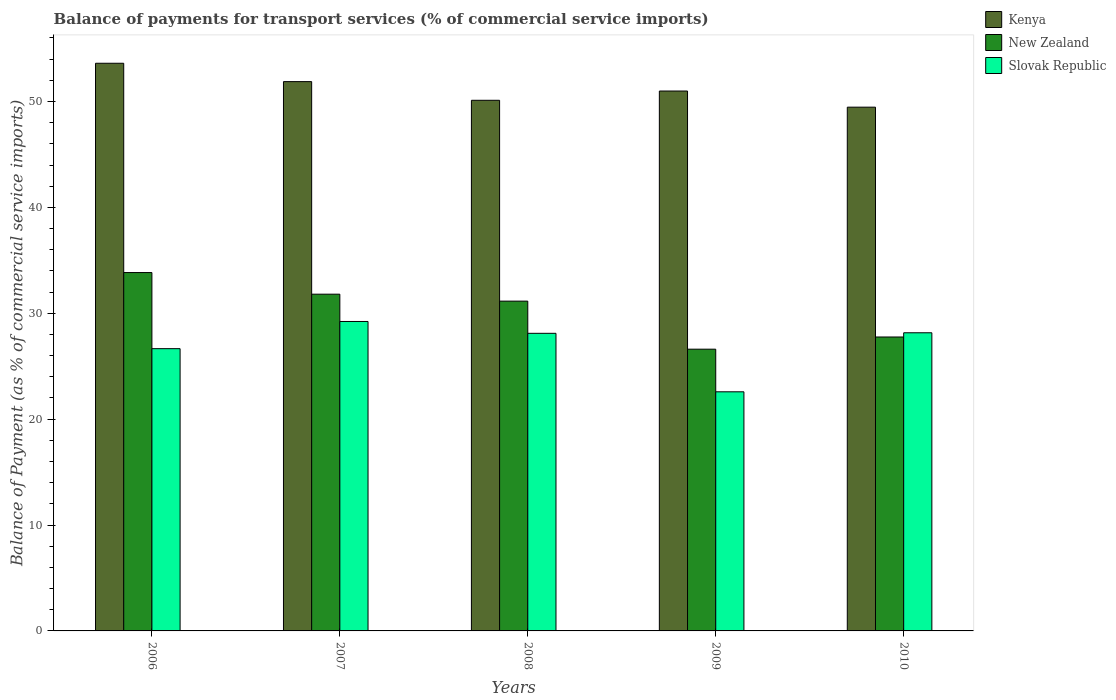How many different coloured bars are there?
Ensure brevity in your answer.  3. How many groups of bars are there?
Your answer should be very brief. 5. Are the number of bars per tick equal to the number of legend labels?
Keep it short and to the point. Yes. Are the number of bars on each tick of the X-axis equal?
Your answer should be very brief. Yes. What is the label of the 3rd group of bars from the left?
Give a very brief answer. 2008. In how many cases, is the number of bars for a given year not equal to the number of legend labels?
Make the answer very short. 0. What is the balance of payments for transport services in New Zealand in 2007?
Make the answer very short. 31.8. Across all years, what is the maximum balance of payments for transport services in Slovak Republic?
Your answer should be very brief. 29.23. Across all years, what is the minimum balance of payments for transport services in New Zealand?
Give a very brief answer. 26.61. In which year was the balance of payments for transport services in Kenya maximum?
Give a very brief answer. 2006. What is the total balance of payments for transport services in Slovak Republic in the graph?
Provide a short and direct response. 134.74. What is the difference between the balance of payments for transport services in Kenya in 2009 and that in 2010?
Make the answer very short. 1.53. What is the difference between the balance of payments for transport services in Slovak Republic in 2010 and the balance of payments for transport services in Kenya in 2009?
Provide a succinct answer. -22.83. What is the average balance of payments for transport services in Kenya per year?
Your response must be concise. 51.21. In the year 2009, what is the difference between the balance of payments for transport services in Slovak Republic and balance of payments for transport services in Kenya?
Offer a very short reply. -28.41. What is the ratio of the balance of payments for transport services in Slovak Republic in 2006 to that in 2010?
Keep it short and to the point. 0.95. What is the difference between the highest and the second highest balance of payments for transport services in Kenya?
Provide a short and direct response. 1.73. What is the difference between the highest and the lowest balance of payments for transport services in New Zealand?
Offer a very short reply. 7.24. In how many years, is the balance of payments for transport services in New Zealand greater than the average balance of payments for transport services in New Zealand taken over all years?
Your answer should be very brief. 3. Is the sum of the balance of payments for transport services in New Zealand in 2008 and 2009 greater than the maximum balance of payments for transport services in Slovak Republic across all years?
Give a very brief answer. Yes. What does the 3rd bar from the left in 2009 represents?
Provide a succinct answer. Slovak Republic. What does the 1st bar from the right in 2006 represents?
Your response must be concise. Slovak Republic. Is it the case that in every year, the sum of the balance of payments for transport services in Slovak Republic and balance of payments for transport services in New Zealand is greater than the balance of payments for transport services in Kenya?
Ensure brevity in your answer.  No. Are all the bars in the graph horizontal?
Make the answer very short. No. How many years are there in the graph?
Give a very brief answer. 5. What is the title of the graph?
Provide a succinct answer. Balance of payments for transport services (% of commercial service imports). Does "Korea (Republic)" appear as one of the legend labels in the graph?
Make the answer very short. No. What is the label or title of the X-axis?
Make the answer very short. Years. What is the label or title of the Y-axis?
Ensure brevity in your answer.  Balance of Payment (as % of commercial service imports). What is the Balance of Payment (as % of commercial service imports) in Kenya in 2006?
Your response must be concise. 53.61. What is the Balance of Payment (as % of commercial service imports) of New Zealand in 2006?
Keep it short and to the point. 33.85. What is the Balance of Payment (as % of commercial service imports) in Slovak Republic in 2006?
Your answer should be very brief. 26.66. What is the Balance of Payment (as % of commercial service imports) in Kenya in 2007?
Give a very brief answer. 51.88. What is the Balance of Payment (as % of commercial service imports) of New Zealand in 2007?
Provide a succinct answer. 31.8. What is the Balance of Payment (as % of commercial service imports) in Slovak Republic in 2007?
Ensure brevity in your answer.  29.23. What is the Balance of Payment (as % of commercial service imports) in Kenya in 2008?
Provide a short and direct response. 50.12. What is the Balance of Payment (as % of commercial service imports) in New Zealand in 2008?
Your answer should be compact. 31.15. What is the Balance of Payment (as % of commercial service imports) in Slovak Republic in 2008?
Ensure brevity in your answer.  28.11. What is the Balance of Payment (as % of commercial service imports) in Kenya in 2009?
Offer a very short reply. 50.99. What is the Balance of Payment (as % of commercial service imports) of New Zealand in 2009?
Your response must be concise. 26.61. What is the Balance of Payment (as % of commercial service imports) in Slovak Republic in 2009?
Give a very brief answer. 22.58. What is the Balance of Payment (as % of commercial service imports) of Kenya in 2010?
Offer a very short reply. 49.47. What is the Balance of Payment (as % of commercial service imports) of New Zealand in 2010?
Offer a very short reply. 27.76. What is the Balance of Payment (as % of commercial service imports) in Slovak Republic in 2010?
Provide a succinct answer. 28.16. Across all years, what is the maximum Balance of Payment (as % of commercial service imports) in Kenya?
Your answer should be very brief. 53.61. Across all years, what is the maximum Balance of Payment (as % of commercial service imports) in New Zealand?
Offer a very short reply. 33.85. Across all years, what is the maximum Balance of Payment (as % of commercial service imports) of Slovak Republic?
Keep it short and to the point. 29.23. Across all years, what is the minimum Balance of Payment (as % of commercial service imports) of Kenya?
Offer a very short reply. 49.47. Across all years, what is the minimum Balance of Payment (as % of commercial service imports) of New Zealand?
Keep it short and to the point. 26.61. Across all years, what is the minimum Balance of Payment (as % of commercial service imports) of Slovak Republic?
Offer a terse response. 22.58. What is the total Balance of Payment (as % of commercial service imports) in Kenya in the graph?
Give a very brief answer. 256.07. What is the total Balance of Payment (as % of commercial service imports) in New Zealand in the graph?
Make the answer very short. 151.17. What is the total Balance of Payment (as % of commercial service imports) in Slovak Republic in the graph?
Provide a succinct answer. 134.74. What is the difference between the Balance of Payment (as % of commercial service imports) in Kenya in 2006 and that in 2007?
Keep it short and to the point. 1.73. What is the difference between the Balance of Payment (as % of commercial service imports) in New Zealand in 2006 and that in 2007?
Your answer should be very brief. 2.04. What is the difference between the Balance of Payment (as % of commercial service imports) in Slovak Republic in 2006 and that in 2007?
Provide a short and direct response. -2.57. What is the difference between the Balance of Payment (as % of commercial service imports) of Kenya in 2006 and that in 2008?
Your answer should be compact. 3.5. What is the difference between the Balance of Payment (as % of commercial service imports) of New Zealand in 2006 and that in 2008?
Keep it short and to the point. 2.7. What is the difference between the Balance of Payment (as % of commercial service imports) of Slovak Republic in 2006 and that in 2008?
Offer a very short reply. -1.45. What is the difference between the Balance of Payment (as % of commercial service imports) in Kenya in 2006 and that in 2009?
Offer a very short reply. 2.62. What is the difference between the Balance of Payment (as % of commercial service imports) of New Zealand in 2006 and that in 2009?
Give a very brief answer. 7.24. What is the difference between the Balance of Payment (as % of commercial service imports) in Slovak Republic in 2006 and that in 2009?
Provide a succinct answer. 4.08. What is the difference between the Balance of Payment (as % of commercial service imports) of Kenya in 2006 and that in 2010?
Give a very brief answer. 4.15. What is the difference between the Balance of Payment (as % of commercial service imports) of New Zealand in 2006 and that in 2010?
Keep it short and to the point. 6.09. What is the difference between the Balance of Payment (as % of commercial service imports) of Slovak Republic in 2006 and that in 2010?
Keep it short and to the point. -1.5. What is the difference between the Balance of Payment (as % of commercial service imports) in Kenya in 2007 and that in 2008?
Make the answer very short. 1.76. What is the difference between the Balance of Payment (as % of commercial service imports) of New Zealand in 2007 and that in 2008?
Keep it short and to the point. 0.66. What is the difference between the Balance of Payment (as % of commercial service imports) in Slovak Republic in 2007 and that in 2008?
Make the answer very short. 1.12. What is the difference between the Balance of Payment (as % of commercial service imports) of Kenya in 2007 and that in 2009?
Keep it short and to the point. 0.89. What is the difference between the Balance of Payment (as % of commercial service imports) in New Zealand in 2007 and that in 2009?
Give a very brief answer. 5.2. What is the difference between the Balance of Payment (as % of commercial service imports) in Slovak Republic in 2007 and that in 2009?
Give a very brief answer. 6.64. What is the difference between the Balance of Payment (as % of commercial service imports) in Kenya in 2007 and that in 2010?
Ensure brevity in your answer.  2.41. What is the difference between the Balance of Payment (as % of commercial service imports) of New Zealand in 2007 and that in 2010?
Provide a succinct answer. 4.04. What is the difference between the Balance of Payment (as % of commercial service imports) of Slovak Republic in 2007 and that in 2010?
Provide a succinct answer. 1.07. What is the difference between the Balance of Payment (as % of commercial service imports) in Kenya in 2008 and that in 2009?
Your answer should be very brief. -0.87. What is the difference between the Balance of Payment (as % of commercial service imports) in New Zealand in 2008 and that in 2009?
Keep it short and to the point. 4.54. What is the difference between the Balance of Payment (as % of commercial service imports) of Slovak Republic in 2008 and that in 2009?
Ensure brevity in your answer.  5.52. What is the difference between the Balance of Payment (as % of commercial service imports) of Kenya in 2008 and that in 2010?
Make the answer very short. 0.65. What is the difference between the Balance of Payment (as % of commercial service imports) of New Zealand in 2008 and that in 2010?
Your answer should be very brief. 3.39. What is the difference between the Balance of Payment (as % of commercial service imports) of Slovak Republic in 2008 and that in 2010?
Your answer should be compact. -0.05. What is the difference between the Balance of Payment (as % of commercial service imports) in Kenya in 2009 and that in 2010?
Provide a short and direct response. 1.53. What is the difference between the Balance of Payment (as % of commercial service imports) of New Zealand in 2009 and that in 2010?
Keep it short and to the point. -1.15. What is the difference between the Balance of Payment (as % of commercial service imports) in Slovak Republic in 2009 and that in 2010?
Provide a short and direct response. -5.57. What is the difference between the Balance of Payment (as % of commercial service imports) in Kenya in 2006 and the Balance of Payment (as % of commercial service imports) in New Zealand in 2007?
Offer a terse response. 21.81. What is the difference between the Balance of Payment (as % of commercial service imports) of Kenya in 2006 and the Balance of Payment (as % of commercial service imports) of Slovak Republic in 2007?
Provide a short and direct response. 24.39. What is the difference between the Balance of Payment (as % of commercial service imports) of New Zealand in 2006 and the Balance of Payment (as % of commercial service imports) of Slovak Republic in 2007?
Provide a short and direct response. 4.62. What is the difference between the Balance of Payment (as % of commercial service imports) of Kenya in 2006 and the Balance of Payment (as % of commercial service imports) of New Zealand in 2008?
Make the answer very short. 22.47. What is the difference between the Balance of Payment (as % of commercial service imports) in Kenya in 2006 and the Balance of Payment (as % of commercial service imports) in Slovak Republic in 2008?
Offer a very short reply. 25.51. What is the difference between the Balance of Payment (as % of commercial service imports) of New Zealand in 2006 and the Balance of Payment (as % of commercial service imports) of Slovak Republic in 2008?
Your response must be concise. 5.74. What is the difference between the Balance of Payment (as % of commercial service imports) of Kenya in 2006 and the Balance of Payment (as % of commercial service imports) of New Zealand in 2009?
Provide a succinct answer. 27. What is the difference between the Balance of Payment (as % of commercial service imports) in Kenya in 2006 and the Balance of Payment (as % of commercial service imports) in Slovak Republic in 2009?
Offer a very short reply. 31.03. What is the difference between the Balance of Payment (as % of commercial service imports) in New Zealand in 2006 and the Balance of Payment (as % of commercial service imports) in Slovak Republic in 2009?
Your answer should be very brief. 11.26. What is the difference between the Balance of Payment (as % of commercial service imports) in Kenya in 2006 and the Balance of Payment (as % of commercial service imports) in New Zealand in 2010?
Your answer should be very brief. 25.85. What is the difference between the Balance of Payment (as % of commercial service imports) in Kenya in 2006 and the Balance of Payment (as % of commercial service imports) in Slovak Republic in 2010?
Your answer should be very brief. 25.46. What is the difference between the Balance of Payment (as % of commercial service imports) in New Zealand in 2006 and the Balance of Payment (as % of commercial service imports) in Slovak Republic in 2010?
Offer a very short reply. 5.69. What is the difference between the Balance of Payment (as % of commercial service imports) in Kenya in 2007 and the Balance of Payment (as % of commercial service imports) in New Zealand in 2008?
Make the answer very short. 20.73. What is the difference between the Balance of Payment (as % of commercial service imports) in Kenya in 2007 and the Balance of Payment (as % of commercial service imports) in Slovak Republic in 2008?
Provide a succinct answer. 23.77. What is the difference between the Balance of Payment (as % of commercial service imports) in New Zealand in 2007 and the Balance of Payment (as % of commercial service imports) in Slovak Republic in 2008?
Make the answer very short. 3.7. What is the difference between the Balance of Payment (as % of commercial service imports) of Kenya in 2007 and the Balance of Payment (as % of commercial service imports) of New Zealand in 2009?
Make the answer very short. 25.27. What is the difference between the Balance of Payment (as % of commercial service imports) of Kenya in 2007 and the Balance of Payment (as % of commercial service imports) of Slovak Republic in 2009?
Your answer should be very brief. 29.3. What is the difference between the Balance of Payment (as % of commercial service imports) in New Zealand in 2007 and the Balance of Payment (as % of commercial service imports) in Slovak Republic in 2009?
Provide a succinct answer. 9.22. What is the difference between the Balance of Payment (as % of commercial service imports) in Kenya in 2007 and the Balance of Payment (as % of commercial service imports) in New Zealand in 2010?
Make the answer very short. 24.12. What is the difference between the Balance of Payment (as % of commercial service imports) in Kenya in 2007 and the Balance of Payment (as % of commercial service imports) in Slovak Republic in 2010?
Keep it short and to the point. 23.72. What is the difference between the Balance of Payment (as % of commercial service imports) in New Zealand in 2007 and the Balance of Payment (as % of commercial service imports) in Slovak Republic in 2010?
Offer a terse response. 3.65. What is the difference between the Balance of Payment (as % of commercial service imports) of Kenya in 2008 and the Balance of Payment (as % of commercial service imports) of New Zealand in 2009?
Ensure brevity in your answer.  23.51. What is the difference between the Balance of Payment (as % of commercial service imports) of Kenya in 2008 and the Balance of Payment (as % of commercial service imports) of Slovak Republic in 2009?
Your response must be concise. 27.53. What is the difference between the Balance of Payment (as % of commercial service imports) in New Zealand in 2008 and the Balance of Payment (as % of commercial service imports) in Slovak Republic in 2009?
Offer a terse response. 8.56. What is the difference between the Balance of Payment (as % of commercial service imports) of Kenya in 2008 and the Balance of Payment (as % of commercial service imports) of New Zealand in 2010?
Make the answer very short. 22.36. What is the difference between the Balance of Payment (as % of commercial service imports) of Kenya in 2008 and the Balance of Payment (as % of commercial service imports) of Slovak Republic in 2010?
Keep it short and to the point. 21.96. What is the difference between the Balance of Payment (as % of commercial service imports) of New Zealand in 2008 and the Balance of Payment (as % of commercial service imports) of Slovak Republic in 2010?
Provide a succinct answer. 2.99. What is the difference between the Balance of Payment (as % of commercial service imports) of Kenya in 2009 and the Balance of Payment (as % of commercial service imports) of New Zealand in 2010?
Your answer should be very brief. 23.23. What is the difference between the Balance of Payment (as % of commercial service imports) of Kenya in 2009 and the Balance of Payment (as % of commercial service imports) of Slovak Republic in 2010?
Your answer should be compact. 22.83. What is the difference between the Balance of Payment (as % of commercial service imports) of New Zealand in 2009 and the Balance of Payment (as % of commercial service imports) of Slovak Republic in 2010?
Provide a succinct answer. -1.55. What is the average Balance of Payment (as % of commercial service imports) of Kenya per year?
Give a very brief answer. 51.21. What is the average Balance of Payment (as % of commercial service imports) in New Zealand per year?
Make the answer very short. 30.23. What is the average Balance of Payment (as % of commercial service imports) of Slovak Republic per year?
Your answer should be very brief. 26.95. In the year 2006, what is the difference between the Balance of Payment (as % of commercial service imports) in Kenya and Balance of Payment (as % of commercial service imports) in New Zealand?
Offer a terse response. 19.77. In the year 2006, what is the difference between the Balance of Payment (as % of commercial service imports) in Kenya and Balance of Payment (as % of commercial service imports) in Slovak Republic?
Ensure brevity in your answer.  26.96. In the year 2006, what is the difference between the Balance of Payment (as % of commercial service imports) in New Zealand and Balance of Payment (as % of commercial service imports) in Slovak Republic?
Provide a short and direct response. 7.19. In the year 2007, what is the difference between the Balance of Payment (as % of commercial service imports) in Kenya and Balance of Payment (as % of commercial service imports) in New Zealand?
Ensure brevity in your answer.  20.08. In the year 2007, what is the difference between the Balance of Payment (as % of commercial service imports) of Kenya and Balance of Payment (as % of commercial service imports) of Slovak Republic?
Make the answer very short. 22.65. In the year 2007, what is the difference between the Balance of Payment (as % of commercial service imports) in New Zealand and Balance of Payment (as % of commercial service imports) in Slovak Republic?
Your answer should be very brief. 2.58. In the year 2008, what is the difference between the Balance of Payment (as % of commercial service imports) in Kenya and Balance of Payment (as % of commercial service imports) in New Zealand?
Ensure brevity in your answer.  18.97. In the year 2008, what is the difference between the Balance of Payment (as % of commercial service imports) in Kenya and Balance of Payment (as % of commercial service imports) in Slovak Republic?
Provide a succinct answer. 22.01. In the year 2008, what is the difference between the Balance of Payment (as % of commercial service imports) of New Zealand and Balance of Payment (as % of commercial service imports) of Slovak Republic?
Your response must be concise. 3.04. In the year 2009, what is the difference between the Balance of Payment (as % of commercial service imports) in Kenya and Balance of Payment (as % of commercial service imports) in New Zealand?
Offer a very short reply. 24.38. In the year 2009, what is the difference between the Balance of Payment (as % of commercial service imports) of Kenya and Balance of Payment (as % of commercial service imports) of Slovak Republic?
Offer a very short reply. 28.41. In the year 2009, what is the difference between the Balance of Payment (as % of commercial service imports) in New Zealand and Balance of Payment (as % of commercial service imports) in Slovak Republic?
Your response must be concise. 4.03. In the year 2010, what is the difference between the Balance of Payment (as % of commercial service imports) of Kenya and Balance of Payment (as % of commercial service imports) of New Zealand?
Provide a short and direct response. 21.71. In the year 2010, what is the difference between the Balance of Payment (as % of commercial service imports) in Kenya and Balance of Payment (as % of commercial service imports) in Slovak Republic?
Your answer should be very brief. 21.31. In the year 2010, what is the difference between the Balance of Payment (as % of commercial service imports) in New Zealand and Balance of Payment (as % of commercial service imports) in Slovak Republic?
Provide a succinct answer. -0.4. What is the ratio of the Balance of Payment (as % of commercial service imports) in Kenya in 2006 to that in 2007?
Keep it short and to the point. 1.03. What is the ratio of the Balance of Payment (as % of commercial service imports) of New Zealand in 2006 to that in 2007?
Your answer should be very brief. 1.06. What is the ratio of the Balance of Payment (as % of commercial service imports) in Slovak Republic in 2006 to that in 2007?
Your answer should be compact. 0.91. What is the ratio of the Balance of Payment (as % of commercial service imports) in Kenya in 2006 to that in 2008?
Your answer should be compact. 1.07. What is the ratio of the Balance of Payment (as % of commercial service imports) in New Zealand in 2006 to that in 2008?
Offer a terse response. 1.09. What is the ratio of the Balance of Payment (as % of commercial service imports) in Slovak Republic in 2006 to that in 2008?
Your answer should be very brief. 0.95. What is the ratio of the Balance of Payment (as % of commercial service imports) of Kenya in 2006 to that in 2009?
Your answer should be very brief. 1.05. What is the ratio of the Balance of Payment (as % of commercial service imports) in New Zealand in 2006 to that in 2009?
Give a very brief answer. 1.27. What is the ratio of the Balance of Payment (as % of commercial service imports) of Slovak Republic in 2006 to that in 2009?
Make the answer very short. 1.18. What is the ratio of the Balance of Payment (as % of commercial service imports) of Kenya in 2006 to that in 2010?
Keep it short and to the point. 1.08. What is the ratio of the Balance of Payment (as % of commercial service imports) in New Zealand in 2006 to that in 2010?
Your response must be concise. 1.22. What is the ratio of the Balance of Payment (as % of commercial service imports) of Slovak Republic in 2006 to that in 2010?
Your answer should be very brief. 0.95. What is the ratio of the Balance of Payment (as % of commercial service imports) of Kenya in 2007 to that in 2008?
Give a very brief answer. 1.04. What is the ratio of the Balance of Payment (as % of commercial service imports) of New Zealand in 2007 to that in 2008?
Offer a terse response. 1.02. What is the ratio of the Balance of Payment (as % of commercial service imports) in Slovak Republic in 2007 to that in 2008?
Offer a very short reply. 1.04. What is the ratio of the Balance of Payment (as % of commercial service imports) in Kenya in 2007 to that in 2009?
Give a very brief answer. 1.02. What is the ratio of the Balance of Payment (as % of commercial service imports) in New Zealand in 2007 to that in 2009?
Give a very brief answer. 1.2. What is the ratio of the Balance of Payment (as % of commercial service imports) in Slovak Republic in 2007 to that in 2009?
Your answer should be very brief. 1.29. What is the ratio of the Balance of Payment (as % of commercial service imports) of Kenya in 2007 to that in 2010?
Provide a short and direct response. 1.05. What is the ratio of the Balance of Payment (as % of commercial service imports) in New Zealand in 2007 to that in 2010?
Provide a short and direct response. 1.15. What is the ratio of the Balance of Payment (as % of commercial service imports) of Slovak Republic in 2007 to that in 2010?
Your response must be concise. 1.04. What is the ratio of the Balance of Payment (as % of commercial service imports) in Kenya in 2008 to that in 2009?
Your answer should be very brief. 0.98. What is the ratio of the Balance of Payment (as % of commercial service imports) of New Zealand in 2008 to that in 2009?
Offer a very short reply. 1.17. What is the ratio of the Balance of Payment (as % of commercial service imports) of Slovak Republic in 2008 to that in 2009?
Offer a very short reply. 1.24. What is the ratio of the Balance of Payment (as % of commercial service imports) of Kenya in 2008 to that in 2010?
Make the answer very short. 1.01. What is the ratio of the Balance of Payment (as % of commercial service imports) in New Zealand in 2008 to that in 2010?
Offer a terse response. 1.12. What is the ratio of the Balance of Payment (as % of commercial service imports) in Kenya in 2009 to that in 2010?
Your answer should be compact. 1.03. What is the ratio of the Balance of Payment (as % of commercial service imports) in New Zealand in 2009 to that in 2010?
Provide a short and direct response. 0.96. What is the ratio of the Balance of Payment (as % of commercial service imports) of Slovak Republic in 2009 to that in 2010?
Provide a short and direct response. 0.8. What is the difference between the highest and the second highest Balance of Payment (as % of commercial service imports) in Kenya?
Keep it short and to the point. 1.73. What is the difference between the highest and the second highest Balance of Payment (as % of commercial service imports) of New Zealand?
Give a very brief answer. 2.04. What is the difference between the highest and the second highest Balance of Payment (as % of commercial service imports) of Slovak Republic?
Provide a succinct answer. 1.07. What is the difference between the highest and the lowest Balance of Payment (as % of commercial service imports) in Kenya?
Make the answer very short. 4.15. What is the difference between the highest and the lowest Balance of Payment (as % of commercial service imports) in New Zealand?
Provide a succinct answer. 7.24. What is the difference between the highest and the lowest Balance of Payment (as % of commercial service imports) in Slovak Republic?
Keep it short and to the point. 6.64. 